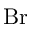<formula> <loc_0><loc_0><loc_500><loc_500>B r</formula> 